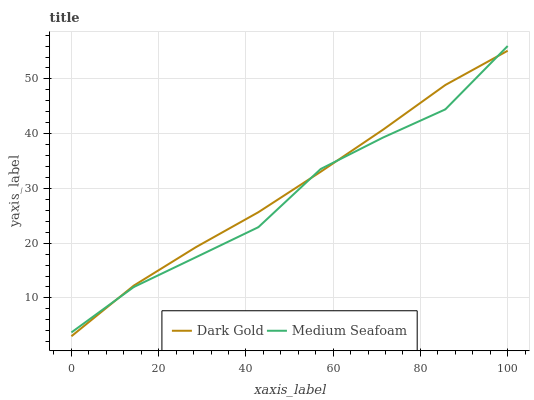Does Medium Seafoam have the minimum area under the curve?
Answer yes or no. Yes. Does Dark Gold have the maximum area under the curve?
Answer yes or no. Yes. Does Dark Gold have the minimum area under the curve?
Answer yes or no. No. Is Dark Gold the smoothest?
Answer yes or no. Yes. Is Medium Seafoam the roughest?
Answer yes or no. Yes. Is Dark Gold the roughest?
Answer yes or no. No. Does Dark Gold have the lowest value?
Answer yes or no. Yes. Does Medium Seafoam have the highest value?
Answer yes or no. Yes. Does Dark Gold have the highest value?
Answer yes or no. No. Does Medium Seafoam intersect Dark Gold?
Answer yes or no. Yes. Is Medium Seafoam less than Dark Gold?
Answer yes or no. No. Is Medium Seafoam greater than Dark Gold?
Answer yes or no. No. 